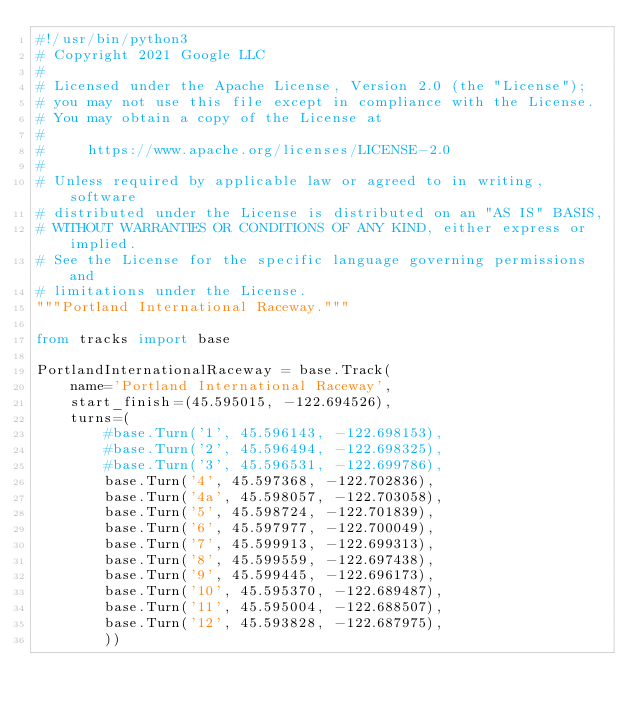Convert code to text. <code><loc_0><loc_0><loc_500><loc_500><_Python_>#!/usr/bin/python3
# Copyright 2021 Google LLC
#
# Licensed under the Apache License, Version 2.0 (the "License");
# you may not use this file except in compliance with the License.
# You may obtain a copy of the License at
#
#     https://www.apache.org/licenses/LICENSE-2.0
#
# Unless required by applicable law or agreed to in writing, software
# distributed under the License is distributed on an "AS IS" BASIS,
# WITHOUT WARRANTIES OR CONDITIONS OF ANY KIND, either express or implied.
# See the License for the specific language governing permissions and
# limitations under the License.
"""Portland International Raceway."""

from tracks import base

PortlandInternationalRaceway = base.Track(
    name='Portland International Raceway',
    start_finish=(45.595015, -122.694526),
    turns=(
        #base.Turn('1', 45.596143, -122.698153),
        #base.Turn('2', 45.596494, -122.698325),
        #base.Turn('3', 45.596531, -122.699786),
        base.Turn('4', 45.597368, -122.702836),
        base.Turn('4a', 45.598057, -122.703058),
        base.Turn('5', 45.598724, -122.701839),
        base.Turn('6', 45.597977, -122.700049),
        base.Turn('7', 45.599913, -122.699313),
        base.Turn('8', 45.599559, -122.697438),
        base.Turn('9', 45.599445, -122.696173),
        base.Turn('10', 45.595370, -122.689487),
        base.Turn('11', 45.595004, -122.688507),
        base.Turn('12', 45.593828, -122.687975),
        ))
</code> 